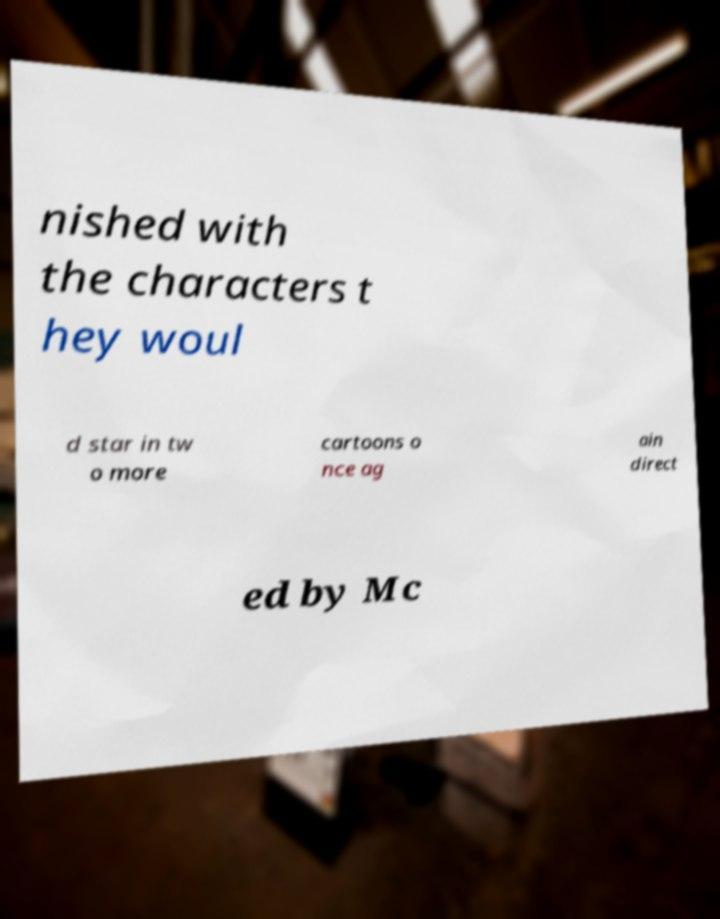For documentation purposes, I need the text within this image transcribed. Could you provide that? nished with the characters t hey woul d star in tw o more cartoons o nce ag ain direct ed by Mc 